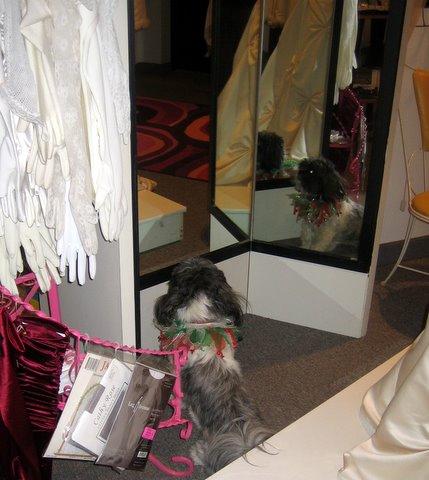How many gloves are there?
Concise answer only. 12. Is there a dog in the mirror?
Short answer required. Yes. What color is the dog?
Write a very short answer. Gray and white. 